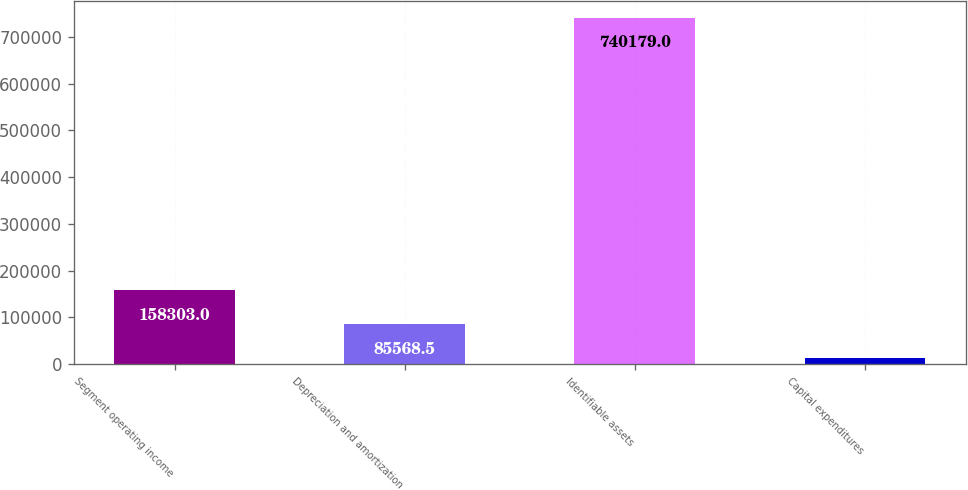Convert chart to OTSL. <chart><loc_0><loc_0><loc_500><loc_500><bar_chart><fcel>Segment operating income<fcel>Depreciation and amortization<fcel>Identifiable assets<fcel>Capital expenditures<nl><fcel>158303<fcel>85568.5<fcel>740179<fcel>12834<nl></chart> 